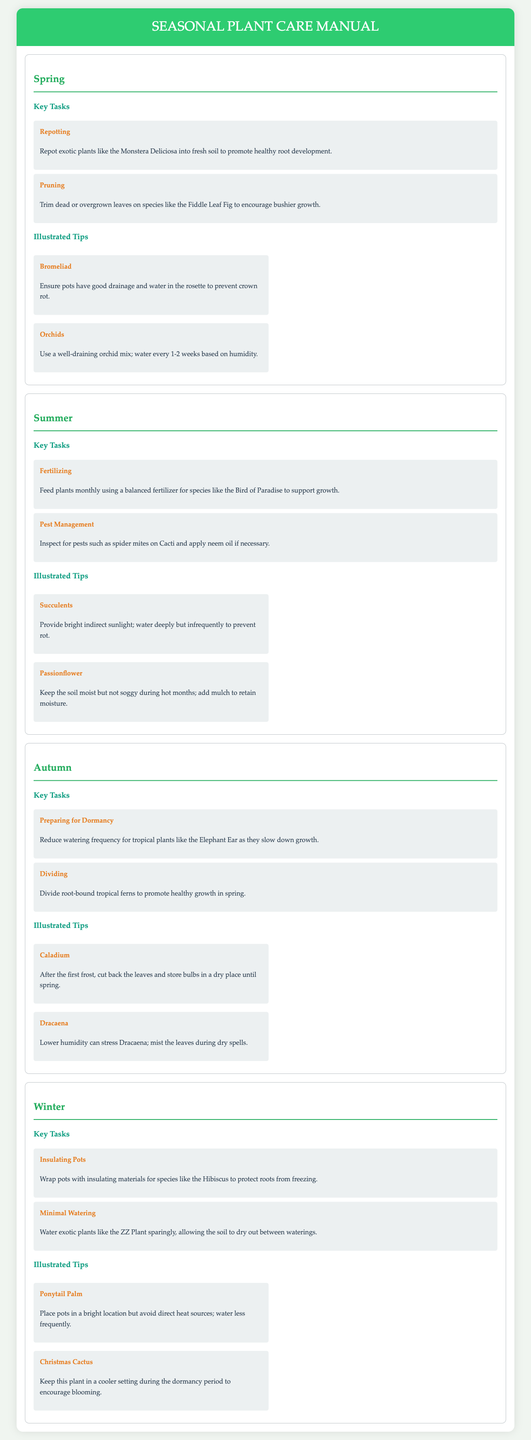What are two key tasks for Spring? The key tasks for Spring include repotting and pruning.
Answer: repotting, pruning How often should orchids be watered? The document states that orchids should be watered every 1-2 weeks based on humidity.
Answer: every 1-2 weeks What is the recommended fertilizer for the Bird of Paradise? The manual suggests using a balanced fertilizer for the Bird of Paradise to support growth.
Answer: balanced fertilizer What should be done with Caladium after the first frost? The document indicates that Caladium leaves should be cut back and bulbs stored in a dry place until spring.
Answer: cut back the leaves and store bulbs Which plant requires minimal watering during winter? The ZZ Plant is specified as needing minimal watering during winter.
Answer: ZZ Plant What should be done for Dracaena during dry spells? The manual advises misting the leaves of Dracaena to alleviate stress caused by lower humidity.
Answer: mist the leaves How should pots be treated in winter for Hibiscus? The document recommends wrapping pots with insulating materials to protect Hibiscus roots from freezing.
Answer: Wrap pots with insulating materials Name an illustrated tip for succulents in summer. The illustrated tip states that succulents should receive bright indirect sunlight and be watered deeply but infrequently.
Answer: bright indirect sunlight; water deeply but infrequently What is the focus of the autumn season tasks? The autumn season tasks primarily focus on preparing tropical plants for dormancy and dividing root-bound ferns.
Answer: preparing for dormancy and dividing ferns 